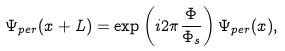<formula> <loc_0><loc_0><loc_500><loc_500>\Psi _ { p e r } ( x + L ) = \exp \left ( i 2 \pi \frac { \Phi } { \Phi _ { s } } \right ) \Psi _ { p e r } ( x ) ,</formula> 